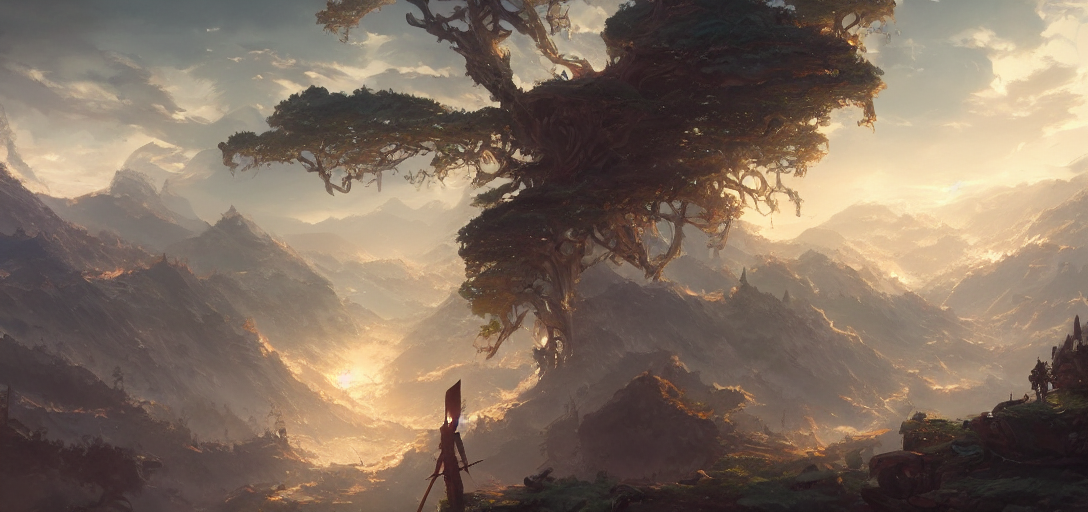Could this setting be from a real place or is it more likely to be imaginary? While inspired by natural elements, the scale and fantasy-like quality of the tree and the surrounding landscape suggest that this setting is more likely to be a product of imagination, designed to evoke wonder and perhaps convey a narrative beyond our own world. 